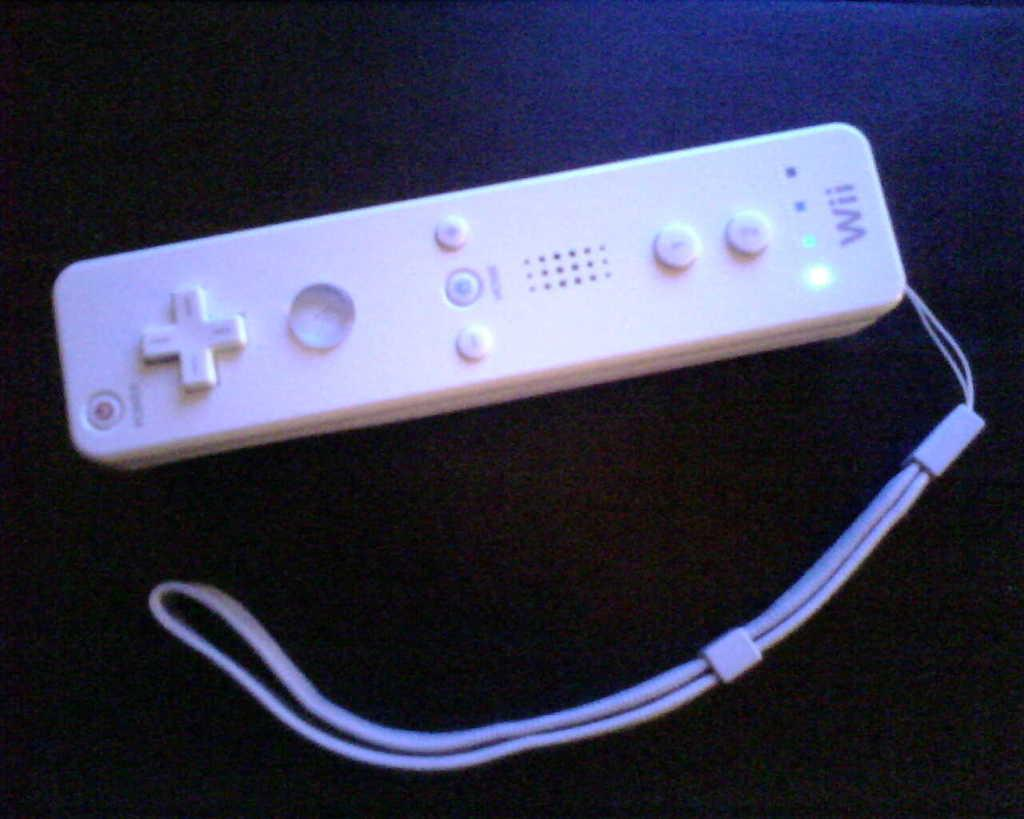What object is visible in the image? There is a remote in the image. What is the color of the surface on which the remote is placed? The remote is on a black color surface. What type of holiday is being celebrated in the image? There is no indication of a holiday being celebrated in the image, as it only features a remote on a black surface. 